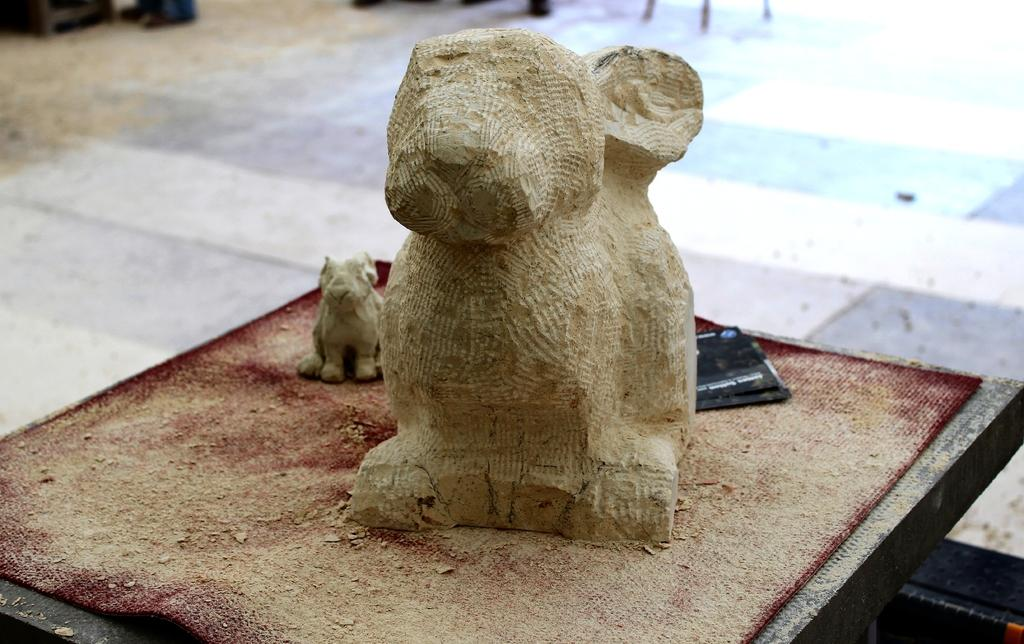What is the main subject of the image? The main subject of the image is a stone. How is the stone depicted in the image? The stone is partially chiseled and in the shape of a dog. What is located at the bottom of the image? There is a mat at the bottom of the image. What type of whistle does the dog in the image have? There is no whistle present in the image; it is a stone sculpture of a dog. How much money is the dog in the image holding? There is no money depicted in the image; it is a stone sculpture of a dog. 